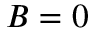Convert formula to latex. <formula><loc_0><loc_0><loc_500><loc_500>B = 0</formula> 